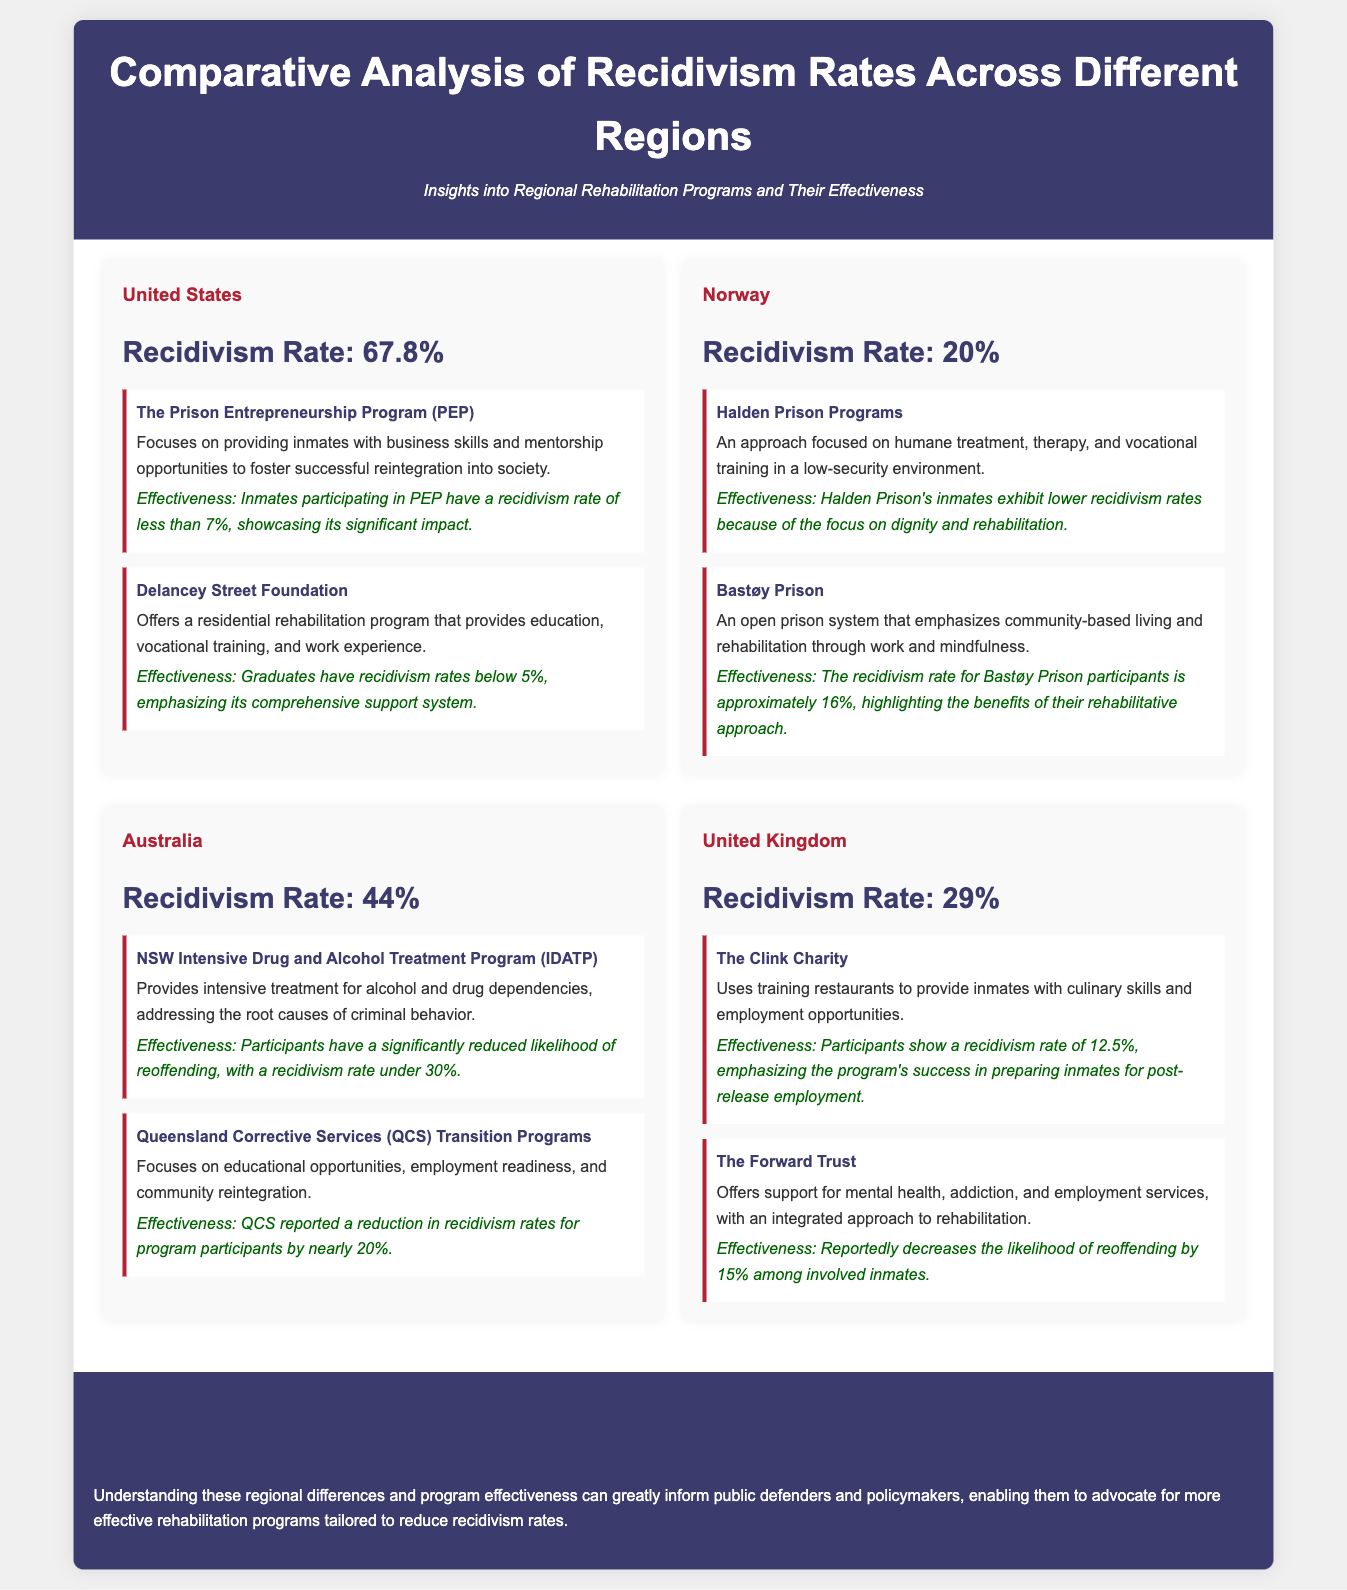What is the recidivism rate in the United States? The recidivism rate for the United States is stated directly in the document under the United States region.
Answer: 67.8% What rehabilitation program in the United States has a recidivism rate of less than 7%? The document mentions the specific program, highlighting its effectiveness in reducing recidivism rates.
Answer: The Prison Entrepreneurship Program (PEP) What is the recidivism rate for Norway? The document explicitly specifies the recidivism rate for Norway under the Norway region.
Answer: 20% Which Australian program focuses on alcohol and drug dependencies? The document indicates two effective programs in Australia; one specifically addresses substance abuse issues.
Answer: NSW Intensive Drug and Alcohol Treatment Program (IDATP) What effect does The Clink Charity have on recidivism rates in the United Kingdom? The Clink Charity's success in reducing recidivism is noted in the program description in the document.
Answer: 12.5% How much does the effectiveness of Queensland Corrective Services (QCS) Transition Programs reduce recidivism rates? The document provides specific information about the impact of this program on recidivism rates, indicating how much they are reduced.
Answer: Nearly 20% What is a common theme among the rehabilitation programs highlighted across different regions? The document refers to the central goal of these programs regarding participants' futures, indicating a broader understanding of rehabilitation.
Answer: Successful reintegration Which region has the highest recidivism rate according to the infographic? The recidivism rates for each region are compared, revealing which region has the highest rate directly in the document.
Answer: United States How does Bastøy Prison emphasize rehabilitation? The document describes Bastøy Prison's rehabilitation methods, indicating how they approach their rehabilitation philosophy.
Answer: Community-based living and rehabilitation through work and mindfulness 